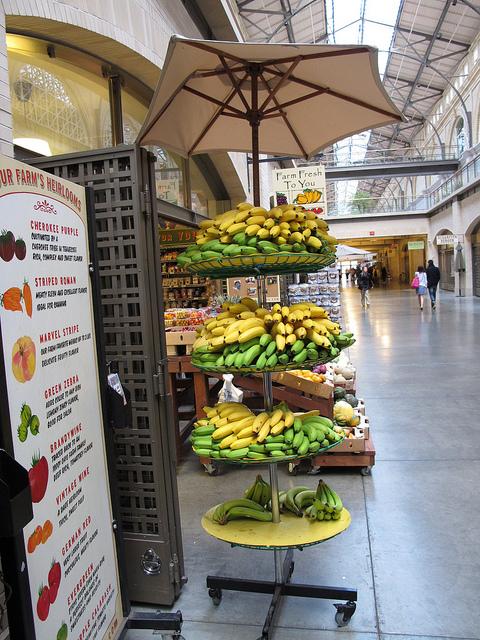Is this a shopping mall?
Be succinct. Yes. Are all of the bananas ripe?
Concise answer only. No. What is above the bananas?
Quick response, please. Umbrella. 